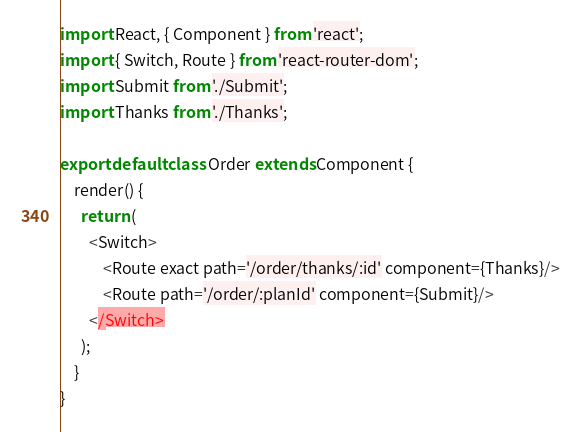<code> <loc_0><loc_0><loc_500><loc_500><_JavaScript_>import React, { Component } from 'react';
import { Switch, Route } from 'react-router-dom';
import Submit from './Submit';
import Thanks from './Thanks';

export default class Order extends Component {
    render() {
      return (
        <Switch>
            <Route exact path='/order/thanks/:id' component={Thanks}/>
            <Route path='/order/:planId' component={Submit}/>
        </Switch>
      );
    }
}</code> 